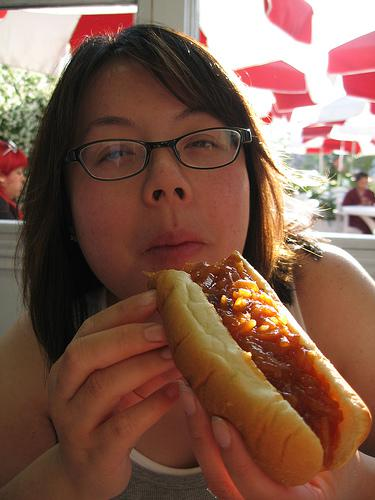Question: who is holding a chili dog?
Choices:
A. The girl.
B. The vendor.
C. The President.
D. Mom.
Answer with the letter. Answer: A Question: what color is the girls hair?
Choices:
A. Red.
B. Brown.
C. White.
D. Black.
Answer with the letter. Answer: B Question: where is the girl?
Choices:
A. In the park.
B. At a restaurant.
C. At school.
D. On a bicycle.
Answer with the letter. Answer: B 